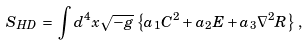Convert formula to latex. <formula><loc_0><loc_0><loc_500><loc_500>S _ { H D } \, = \, \int d ^ { 4 } x \sqrt { - g } \, \left \{ a _ { 1 } C ^ { 2 } + a _ { 2 } E + a _ { 3 } { \nabla ^ { 2 } } R \right \} \, ,</formula> 